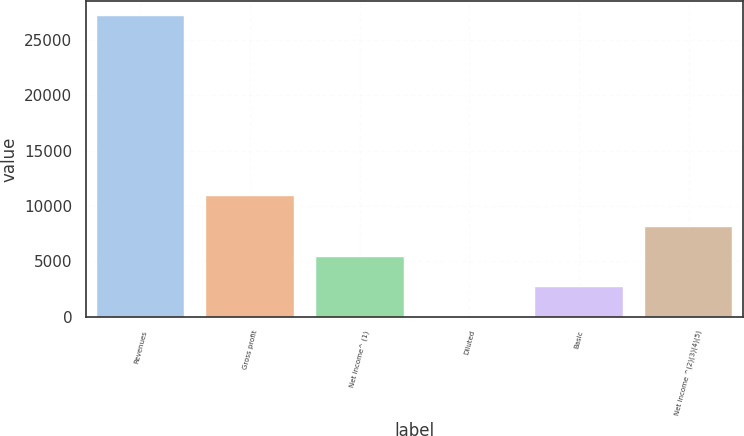<chart> <loc_0><loc_0><loc_500><loc_500><bar_chart><fcel>Revenues<fcel>Gross profit<fcel>Net income^ (1)<fcel>Diluted<fcel>Basic<fcel>Net income ^(2)(3)(4)(5)<nl><fcel>27130<fcel>10852.7<fcel>5426.89<fcel>1.11<fcel>2714<fcel>8139.78<nl></chart> 